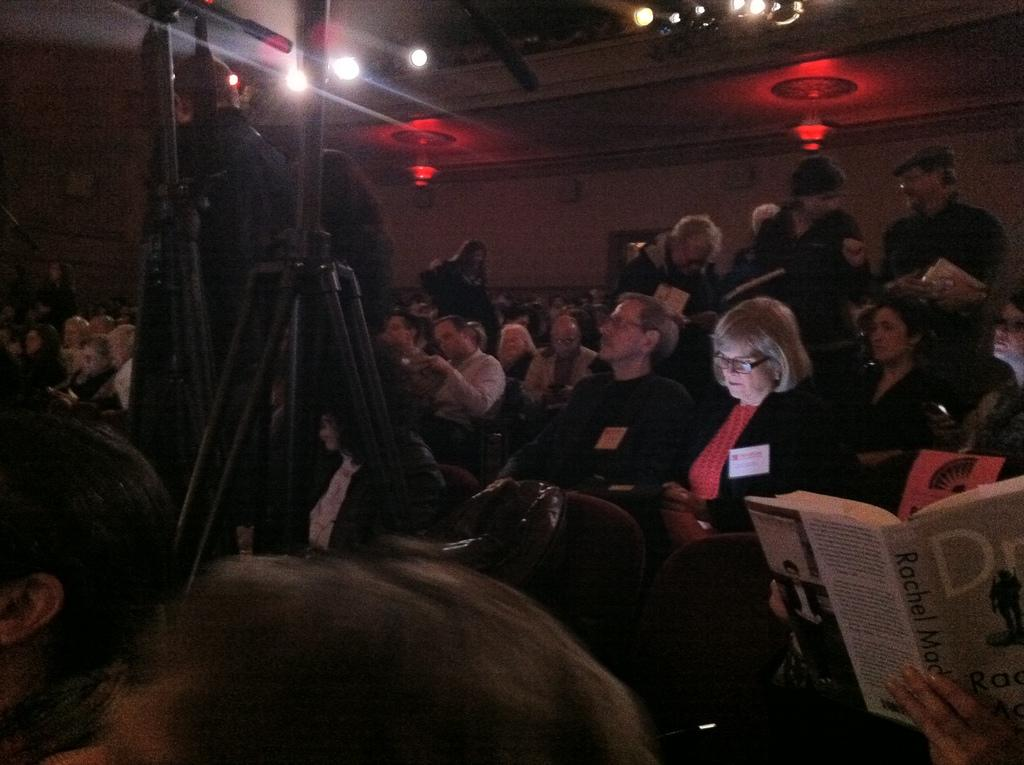Who or what can be seen in the image? There are people in the image. What structures are present in the image? There are poles in the image. What is on the roof in the image? There are lights on the roof in the image. What type of architectural feature is visible in the image? There is a wall in the image. How many eyes can be seen on the people in the image? There is no information about the number of eyes on the people in the image, as we cannot see their eyes directly. 